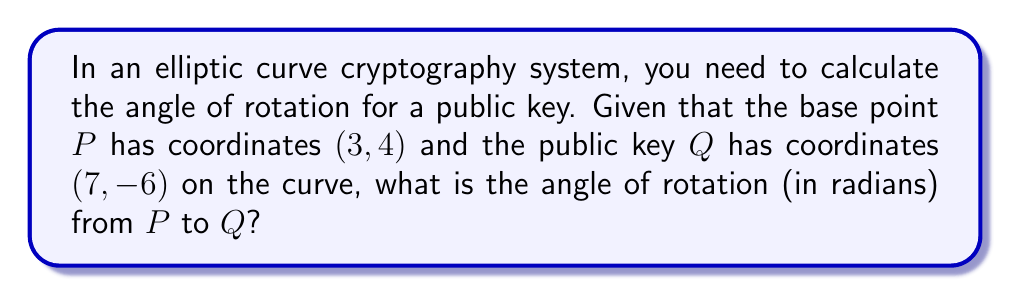Can you answer this question? To calculate the angle of rotation from point P to point Q, we can use the arctangent function. Here's how we proceed:

1. Calculate the differences in x and y coordinates:
   $\Delta x = x_Q - x_P = 7 - 3 = 4$
   $\Delta y = y_Q - y_P = -6 - 4 = -10$

2. The angle of rotation can be calculated using the arctangent function:
   $\theta = \arctan(\frac{\Delta y}{\Delta x})$

3. Substitute the values:
   $\theta = \arctan(\frac{-10}{4})$

4. Simplify:
   $\theta = \arctan(-2.5)$

5. Calculate the result:
   $\theta \approx -1.1902$ radians

Note: The arctangent function returns a value in the range $(-\frac{\pi}{2}, \frac{\pi}{2})$. In cryptography, we often use the principal value of the arctangent, which is what we've calculated here.
Answer: $-1.1902$ radians 